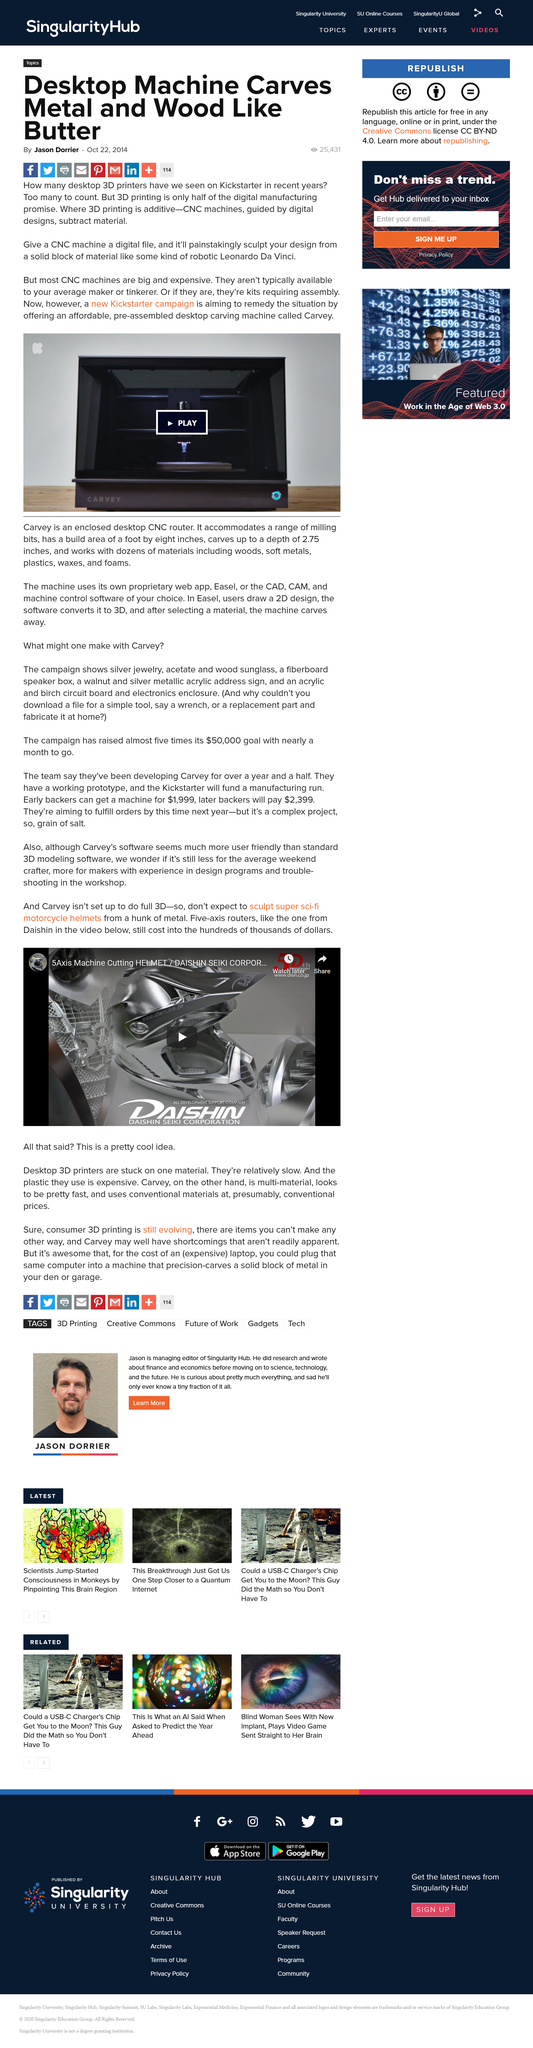Highlight a few significant elements in this photo. The Carvey is an affordable, pre-assembled desktop carving machine that allows for easy and precise carving of a variety of materials, making it a valuable tool for both professionals and hobbyists. When a CNC machine is given a digital file, it meticulously sculpts the design from a solid block of material, exhibiting the same level of precision and skill as a robotic Leonardo da Vinci. The author of this article is Jason Dorrier. 